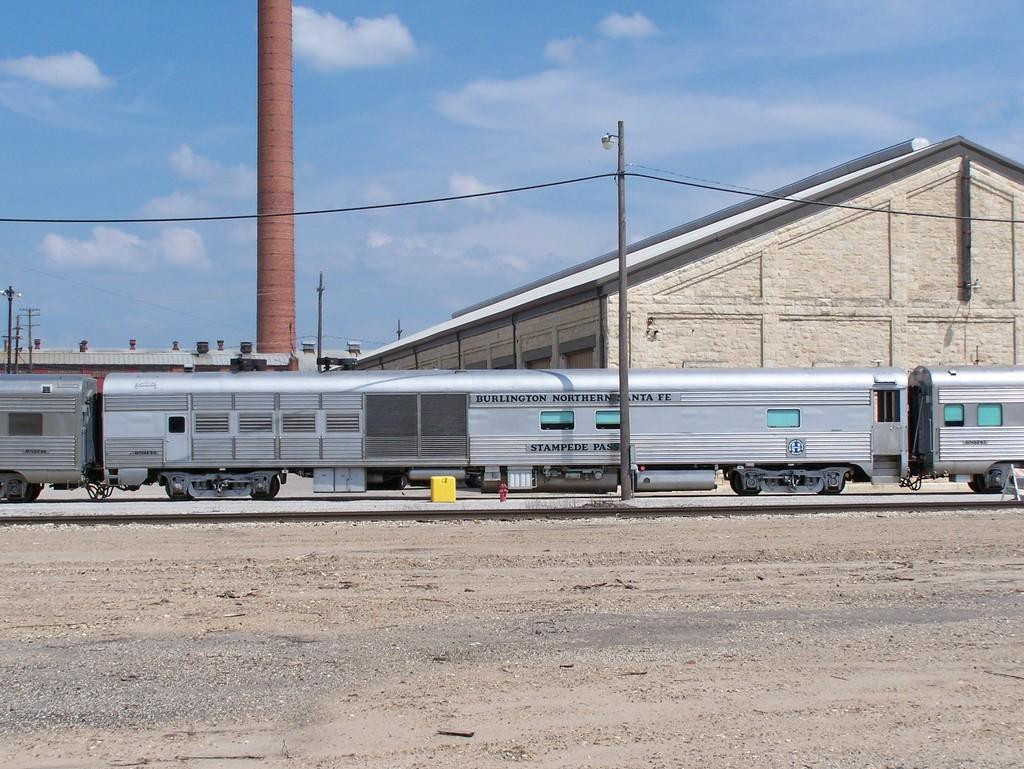<image>
Give a short and clear explanation of the subsequent image. A train with the words Burlington Northern Santa Fe sits on tracks in the desert. 